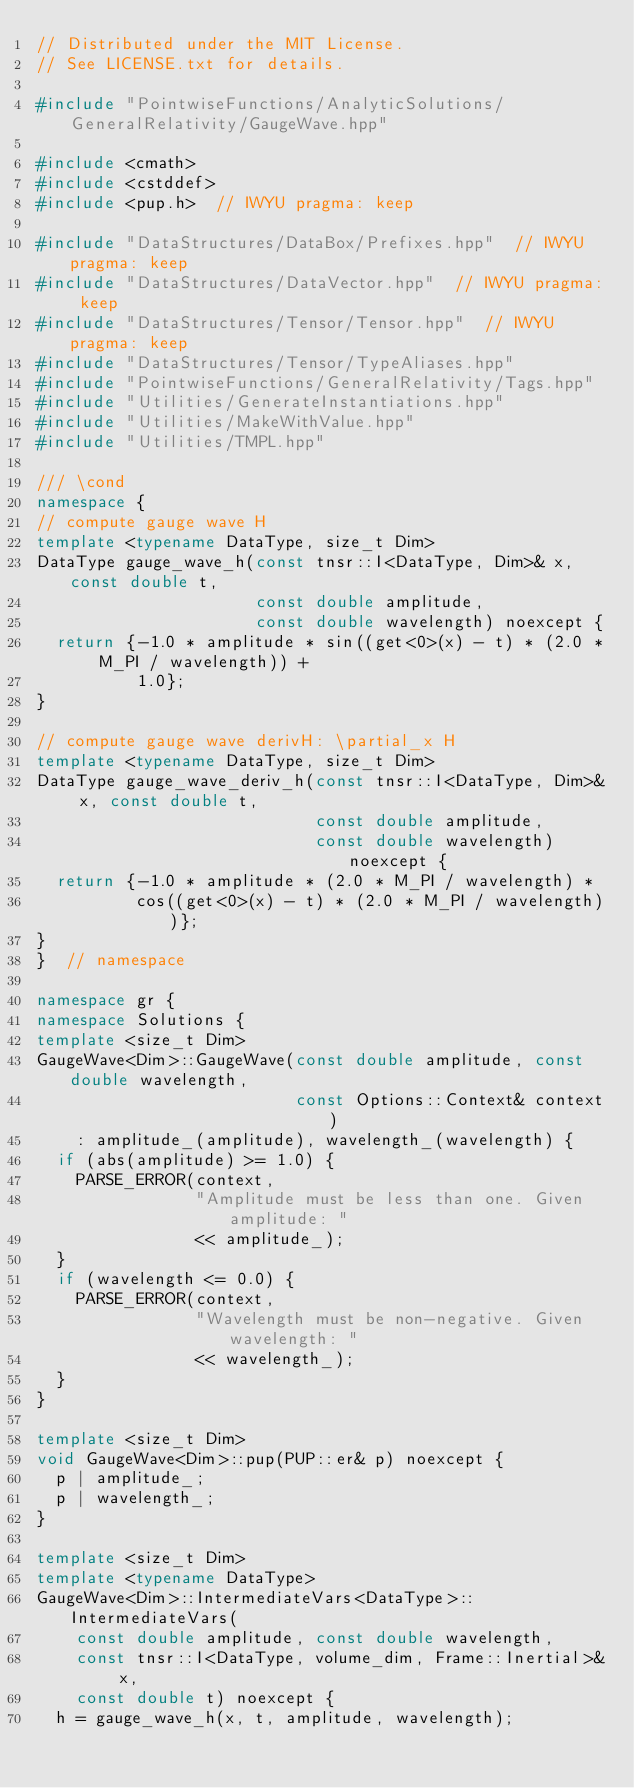<code> <loc_0><loc_0><loc_500><loc_500><_C++_>// Distributed under the MIT License.
// See LICENSE.txt for details.

#include "PointwiseFunctions/AnalyticSolutions/GeneralRelativity/GaugeWave.hpp"

#include <cmath>
#include <cstddef>
#include <pup.h>  // IWYU pragma: keep

#include "DataStructures/DataBox/Prefixes.hpp"  // IWYU pragma: keep
#include "DataStructures/DataVector.hpp"  // IWYU pragma: keep
#include "DataStructures/Tensor/Tensor.hpp"  // IWYU pragma: keep
#include "DataStructures/Tensor/TypeAliases.hpp"
#include "PointwiseFunctions/GeneralRelativity/Tags.hpp"
#include "Utilities/GenerateInstantiations.hpp"
#include "Utilities/MakeWithValue.hpp"
#include "Utilities/TMPL.hpp"

/// \cond
namespace {
// compute gauge wave H
template <typename DataType, size_t Dim>
DataType gauge_wave_h(const tnsr::I<DataType, Dim>& x, const double t,
                      const double amplitude,
                      const double wavelength) noexcept {
  return {-1.0 * amplitude * sin((get<0>(x) - t) * (2.0 * M_PI / wavelength)) +
          1.0};
}

// compute gauge wave derivH: \partial_x H
template <typename DataType, size_t Dim>
DataType gauge_wave_deriv_h(const tnsr::I<DataType, Dim>& x, const double t,
                            const double amplitude,
                            const double wavelength) noexcept {
  return {-1.0 * amplitude * (2.0 * M_PI / wavelength) *
          cos((get<0>(x) - t) * (2.0 * M_PI / wavelength))};
}
}  // namespace

namespace gr {
namespace Solutions {
template <size_t Dim>
GaugeWave<Dim>::GaugeWave(const double amplitude, const double wavelength,
                          const Options::Context& context)
    : amplitude_(amplitude), wavelength_(wavelength) {
  if (abs(amplitude) >= 1.0) {
    PARSE_ERROR(context,
                "Amplitude must be less than one. Given amplitude: "
                << amplitude_);
  }
  if (wavelength <= 0.0) {
    PARSE_ERROR(context,
                "Wavelength must be non-negative. Given wavelength: "
                << wavelength_);
  }
}

template <size_t Dim>
void GaugeWave<Dim>::pup(PUP::er& p) noexcept {
  p | amplitude_;
  p | wavelength_;
}

template <size_t Dim>
template <typename DataType>
GaugeWave<Dim>::IntermediateVars<DataType>::IntermediateVars(
    const double amplitude, const double wavelength,
    const tnsr::I<DataType, volume_dim, Frame::Inertial>& x,
    const double t) noexcept {
  h = gauge_wave_h(x, t, amplitude, wavelength);</code> 